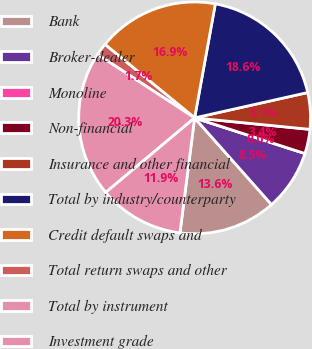Convert chart to OTSL. <chart><loc_0><loc_0><loc_500><loc_500><pie_chart><fcel>Bank<fcel>Broker-dealer<fcel>Monoline<fcel>Non-financial<fcel>Insurance and other financial<fcel>Total by industry/counterparty<fcel>Credit default swaps and<fcel>Total return swaps and other<fcel>Total by instrument<fcel>Investment grade<nl><fcel>13.57%<fcel>8.48%<fcel>0.0%<fcel>3.39%<fcel>5.09%<fcel>18.63%<fcel>16.94%<fcel>1.7%<fcel>20.33%<fcel>11.87%<nl></chart> 